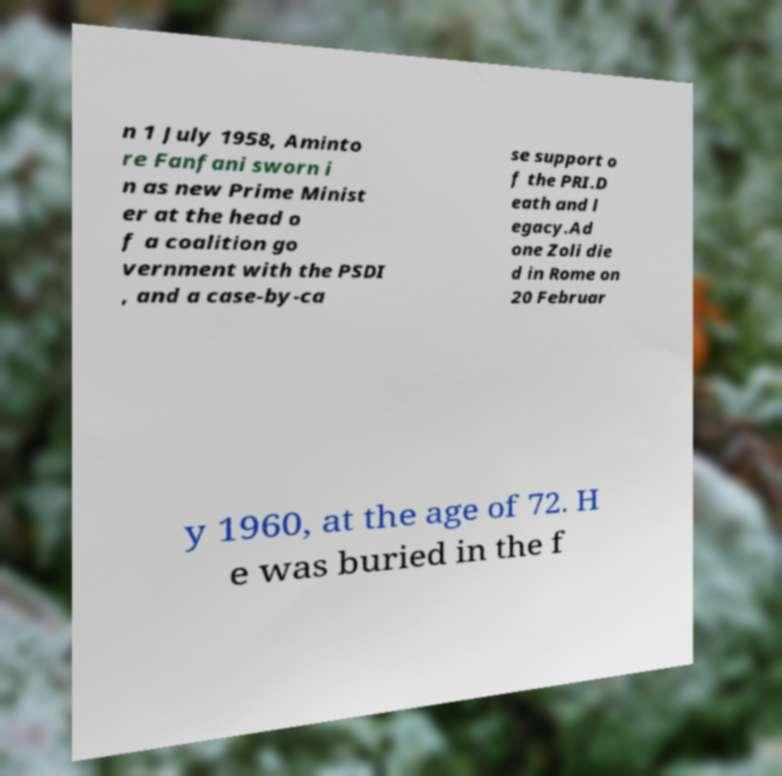Can you accurately transcribe the text from the provided image for me? n 1 July 1958, Aminto re Fanfani sworn i n as new Prime Minist er at the head o f a coalition go vernment with the PSDI , and a case-by-ca se support o f the PRI.D eath and l egacy.Ad one Zoli die d in Rome on 20 Februar y 1960, at the age of 72. H e was buried in the f 